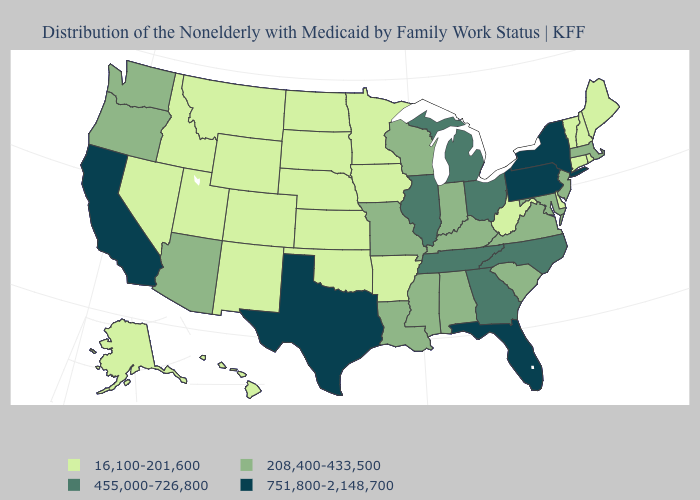What is the lowest value in states that border Rhode Island?
Write a very short answer. 16,100-201,600. Does Nevada have the highest value in the West?
Give a very brief answer. No. Does the map have missing data?
Write a very short answer. No. What is the value of New York?
Concise answer only. 751,800-2,148,700. Does Missouri have a higher value than Kentucky?
Quick response, please. No. Which states hav the highest value in the South?
Write a very short answer. Florida, Texas. Among the states that border Iowa , which have the highest value?
Concise answer only. Illinois. Does Nevada have the lowest value in the West?
Concise answer only. Yes. Name the states that have a value in the range 751,800-2,148,700?
Answer briefly. California, Florida, New York, Pennsylvania, Texas. Name the states that have a value in the range 208,400-433,500?
Write a very short answer. Alabama, Arizona, Indiana, Kentucky, Louisiana, Maryland, Massachusetts, Mississippi, Missouri, New Jersey, Oregon, South Carolina, Virginia, Washington, Wisconsin. What is the lowest value in the USA?
Quick response, please. 16,100-201,600. What is the lowest value in states that border Montana?
Write a very short answer. 16,100-201,600. What is the value of New York?
Keep it brief. 751,800-2,148,700. Does California have the highest value in the West?
Keep it brief. Yes. What is the value of Montana?
Short answer required. 16,100-201,600. 